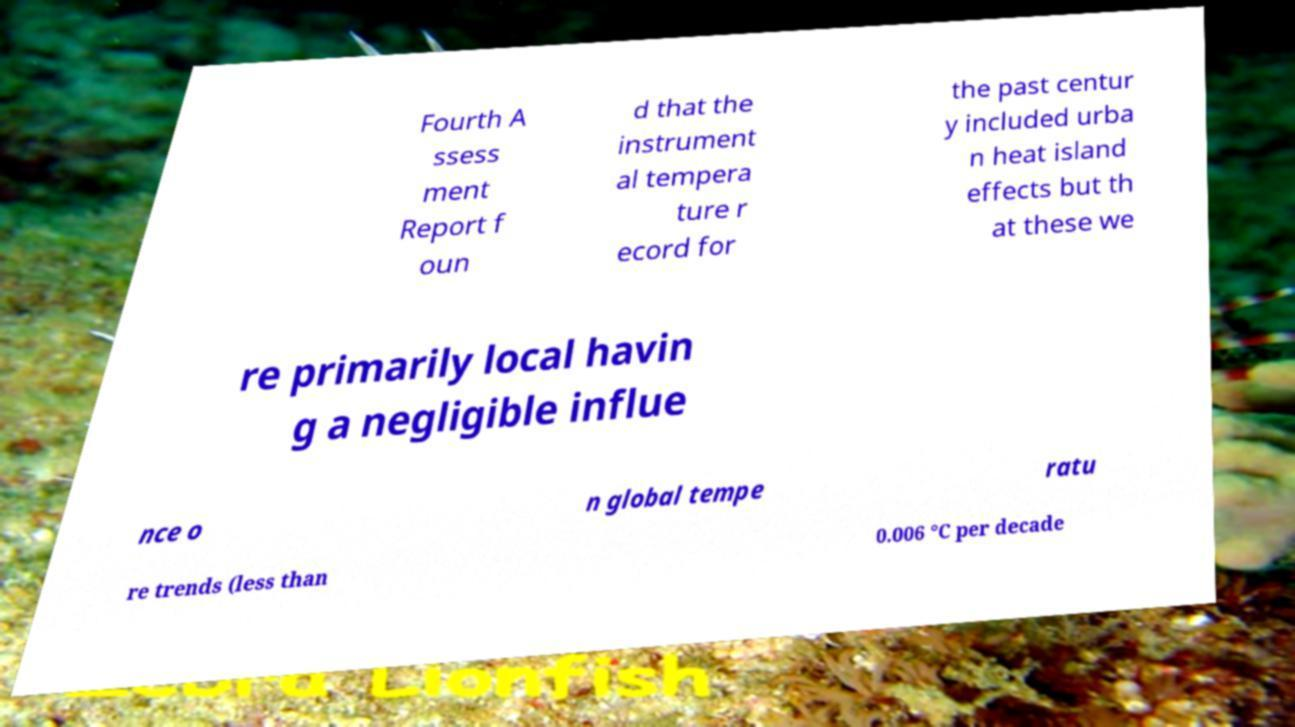Please read and relay the text visible in this image. What does it say? Fourth A ssess ment Report f oun d that the instrument al tempera ture r ecord for the past centur y included urba n heat island effects but th at these we re primarily local havin g a negligible influe nce o n global tempe ratu re trends (less than 0.006 °C per decade 